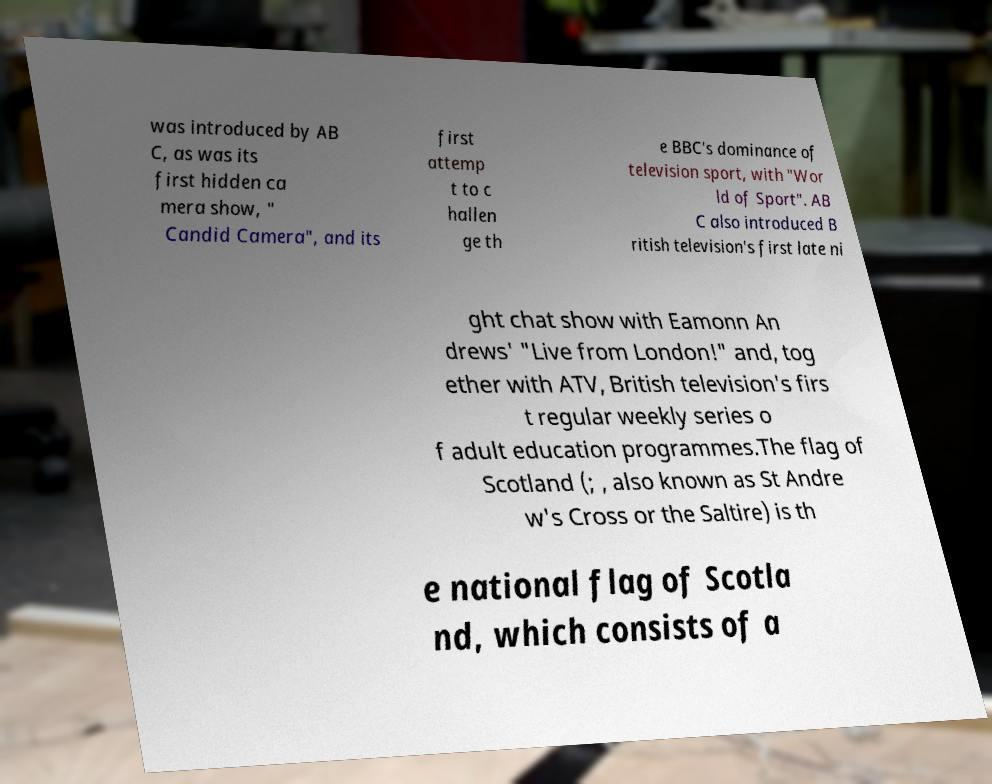What messages or text are displayed in this image? I need them in a readable, typed format. was introduced by AB C, as was its first hidden ca mera show, " Candid Camera", and its first attemp t to c hallen ge th e BBC's dominance of television sport, with "Wor ld of Sport". AB C also introduced B ritish television's first late ni ght chat show with Eamonn An drews' "Live from London!" and, tog ether with ATV, British television's firs t regular weekly series o f adult education programmes.The flag of Scotland (; , also known as St Andre w's Cross or the Saltire) is th e national flag of Scotla nd, which consists of a 